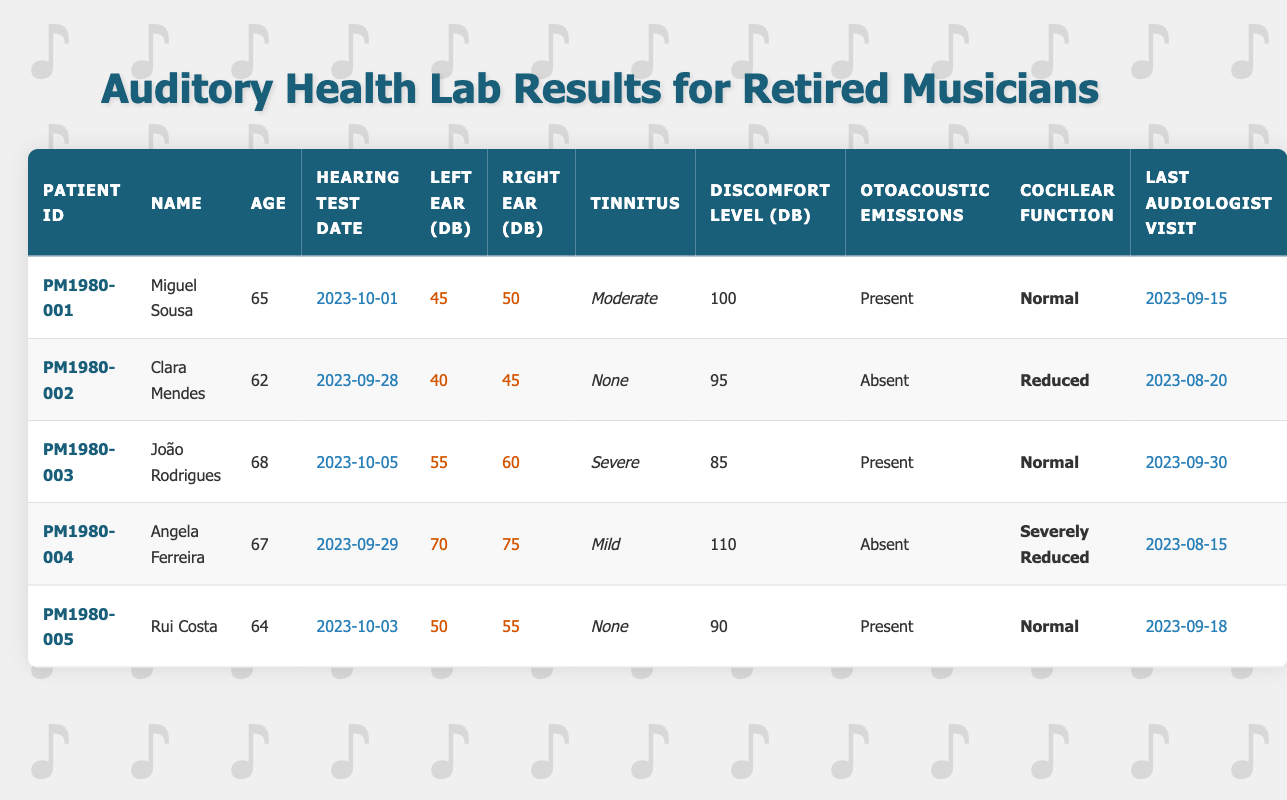What is the audiologist visit date for Miguel Sousa? Miguel Sousa has a record for his last audiologist visit on the date listed in the corresponding column, which shows "2023-09-15".
Answer: 2023-09-15 Which patient has the highest hearing threshold in the left ear? To find the highest hearing threshold in the left ear, I compare the values listed for all patients: 45, 40, 55, 70, and 50 dB. The maximum is 70 dB, which belongs to Angela Ferreira.
Answer: Angela Ferreira Is there any patient with "Normal" cochlear function? I check the cochlear function of each patient in the table. The records show that Miguel Sousa, João Rodrigues, and Rui Costa have "Normal" cochlear function. Since they exist, the answer is yes.
Answer: Yes What is the average auditory discomfort level for patients? To calculate the average, I sum the discomfort levels: 100 + 95 + 85 + 110 + 90 = 480 dB. There are 5 patients, so I divide the total 480 by 5, which gives an average of 96 dB.
Answer: 96 How many patients experience tinnitus? I check the tinnitus column for each patient. The records indicate that Miguel Sousa has "Moderate", João Rodrigues has "Severe", and Angela Ferreira has "Mild". Since three out of five patients experience tinnitus, the answer is three.
Answer: 3 Which patient has the lowest auditory discomfort level? I look through the discomfort levels listed: 100, 95, 85, 110, and 90 dB. The minimum is 85 dB, corresponding to João Rodrigues.
Answer: João Rodrigues Did Clara Mendes have any tinnitus reported? Checking the tinnitus status for Clara Mendes reveals that it is "None". Thus, she did not experience tinnitus.
Answer: No What is the difference in hearing thresholds between João Rodrigues' left ear and Rui Costa's right ear? I need to find the values for João Rodrigues’ left ear (55 dB) and Rui Costa’s right ear (55 dB). The difference calculation is: 55 - 55 = 0 dB.
Answer: 0 